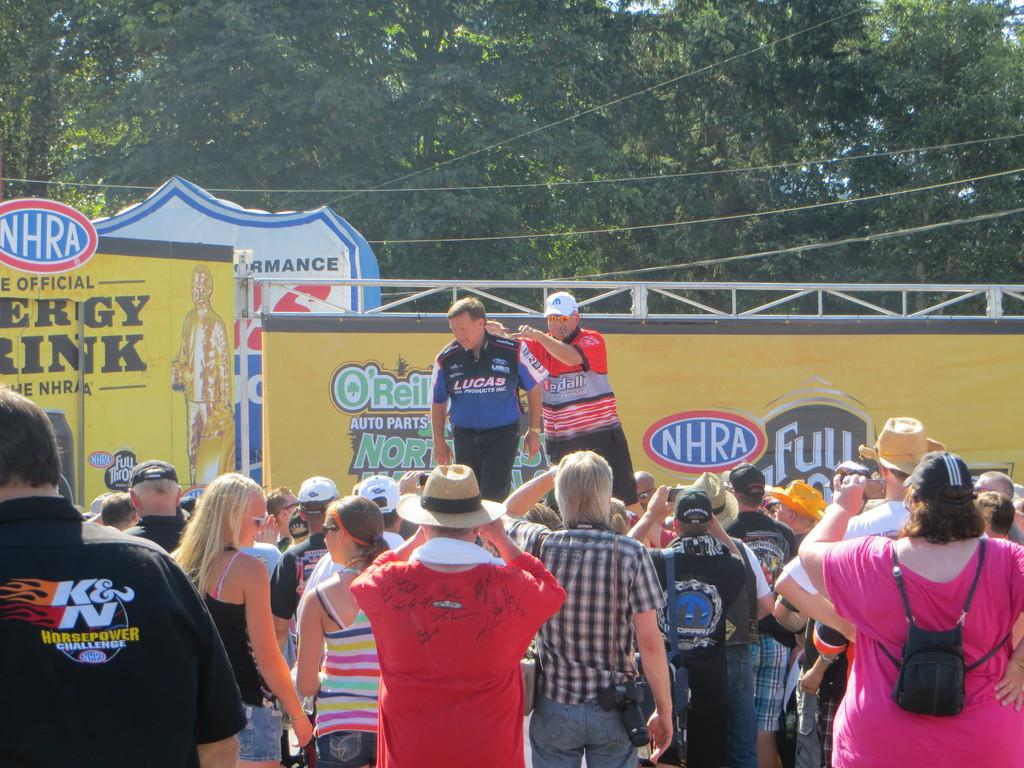How many people can be seen in the image? There are many people standing in the image. Can you identify any specific individuals in the image? Two persons are standing on a stage. What else is present in the image besides the people? There are banners visible in the image. What can be seen in the background of the image? There are trees in the background of the image. What type of yoke is being used by the cow in the image? There is no cow or yoke present in the image. What color is the paint on the cow in the image? There is no cow or paint present in the image. 